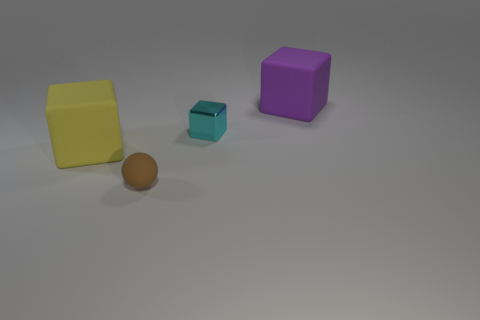What is the shape of the purple object? The purple object is a cube with equal-length sides, giving it a symmetrical geometric shape. 